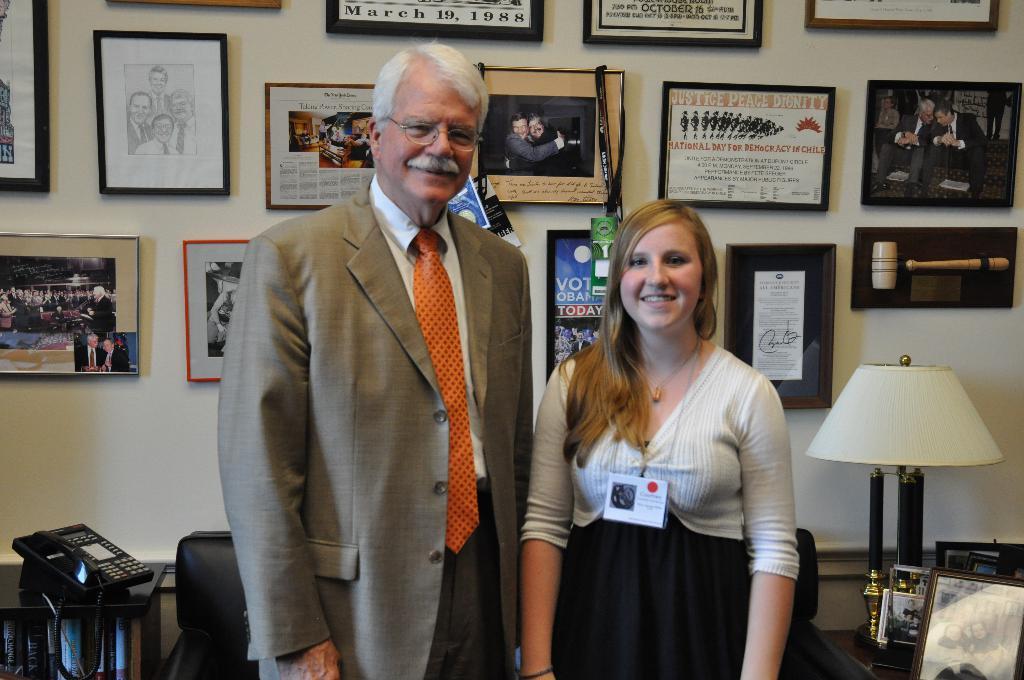When should you vote?
Provide a succinct answer. Today. What is the date on the middle poster at the top of the wall?
Provide a succinct answer. March 19, 1988. 